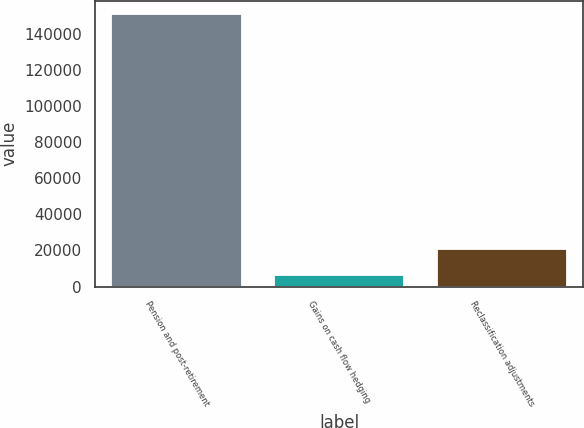<chart> <loc_0><loc_0><loc_500><loc_500><bar_chart><fcel>Pension and post-retirement<fcel>Gains on cash flow hedging<fcel>Reclassification adjustments<nl><fcel>150694<fcel>6390<fcel>20820.4<nl></chart> 